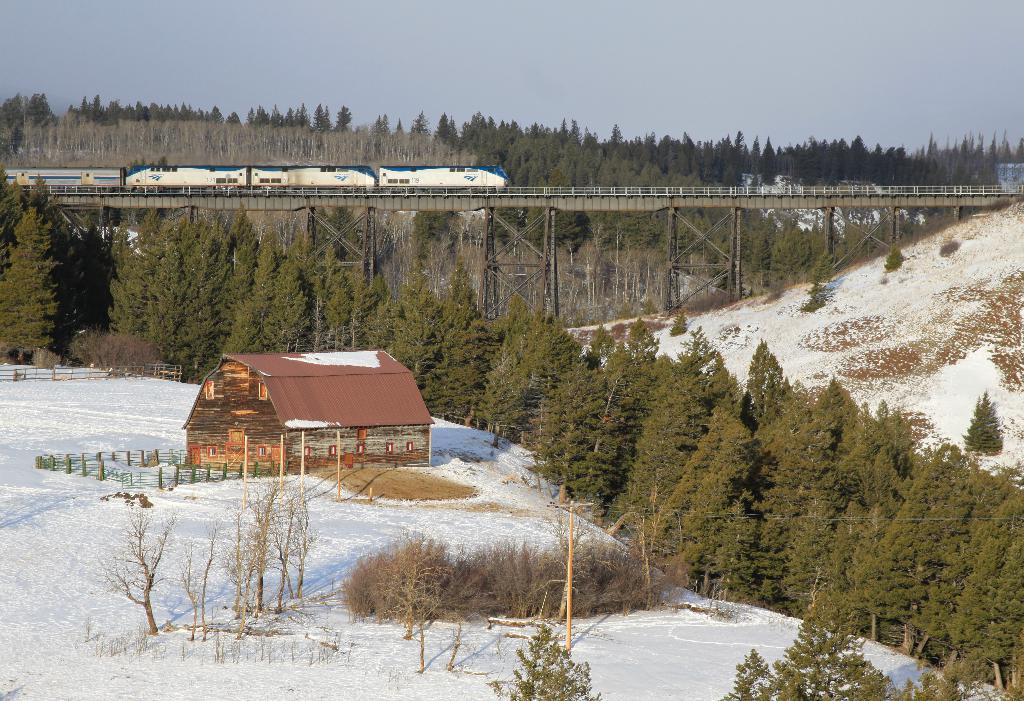What can be seen in the foreground of the image? In the foreground of the image, there are plants, trees, snow, a fence, a house, and a train on a bridge. What type of vegetation is present in the foreground? Both plants and trees are present in the foreground. What is the condition of the ground in the foreground? The ground in the foreground is covered in snow. What structure is visible in the foreground? A house is visible in the foreground. What mode of transportation can be seen in the foreground? A train on a bridge can be seen in the foreground. What is visible at the top of the image? The sky is visible at the top of the image. Based on the presence of snow and the visibility of the sky, what time of day might the image have been taken? The image was likely taken during the day. Where is the island located in the image? There is no island present in the image. What type of cave can be seen in the image? There is no cave present in the image. 